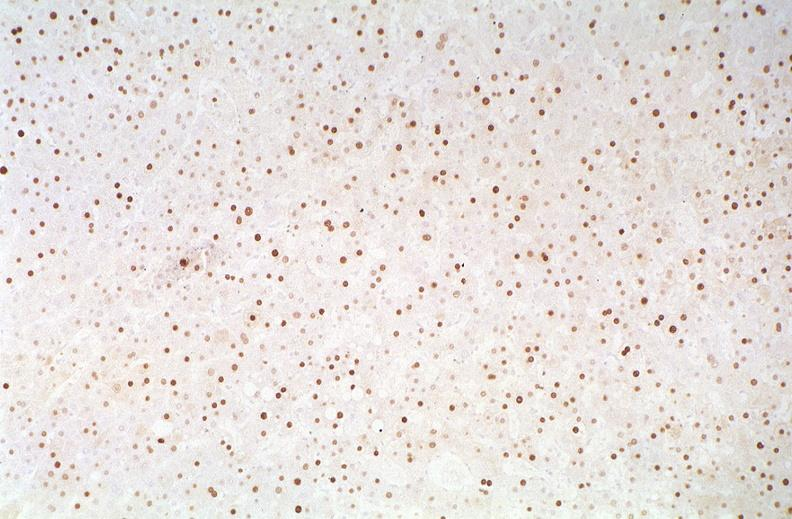s natural color present?
Answer the question using a single word or phrase. No 